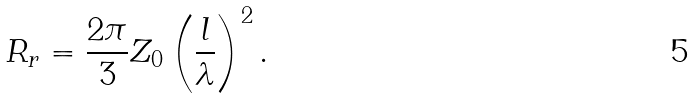Convert formula to latex. <formula><loc_0><loc_0><loc_500><loc_500>R _ { r } = { \frac { 2 \pi } { 3 } } Z _ { 0 } \left ( { \frac { l } { \lambda } } \right ) ^ { 2 } .</formula> 